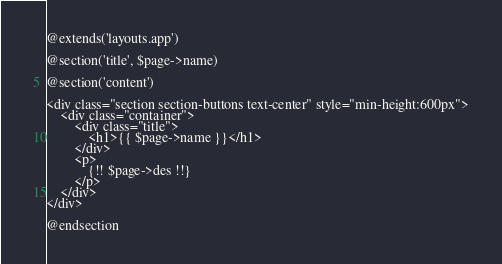<code> <loc_0><loc_0><loc_500><loc_500><_PHP_>@extends('layouts.app')

@section('title', $page->name)

@section('content')

<div class="section section-buttons text-center" style="min-height:600px">
    <div class="container">
        <div class="title">
            <h1>{{ $page->name }}</h1>
        </div>
        <p>
            {!! $page->des !!}
        </p>
    </div>
</div>

@endsection</code> 